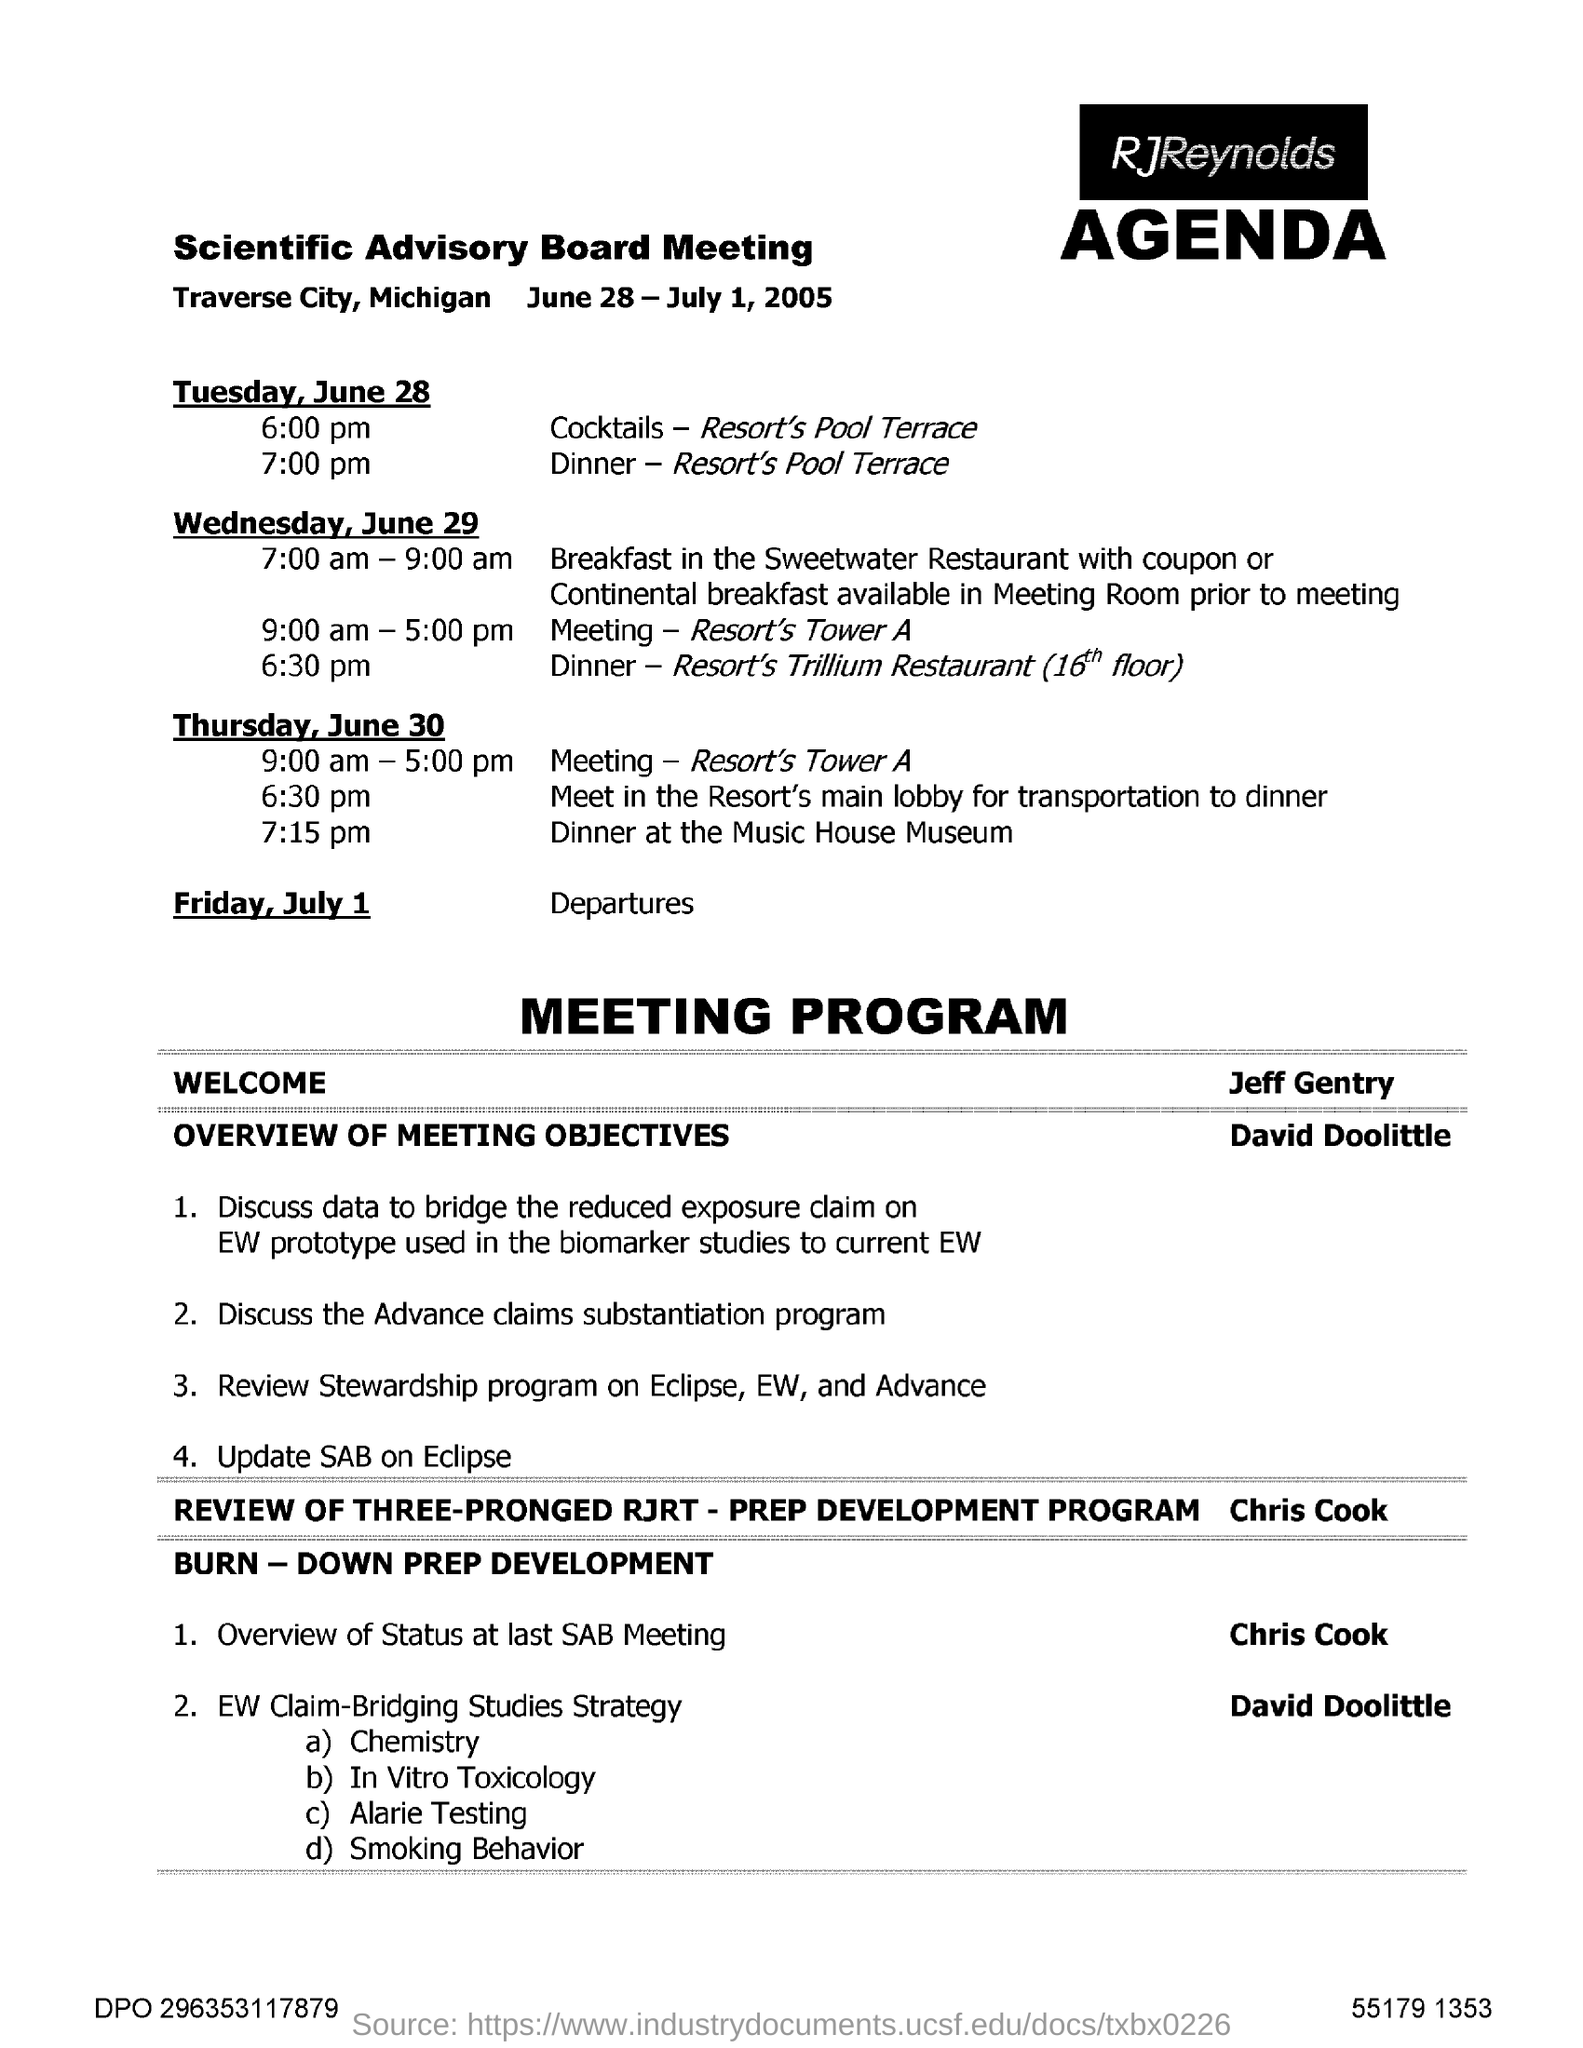When is Scientific Advisory Board Meeting held?
Offer a very short reply. June 28 - July 1, 2005. Where is the Dinner held On Tuesday, June 28?
Your answer should be very brief. Resort's Pool Terrace. Where is the dinner held on Wednesday, June 29?
Your answer should be compact. Resort's Trillium Restaurant. 